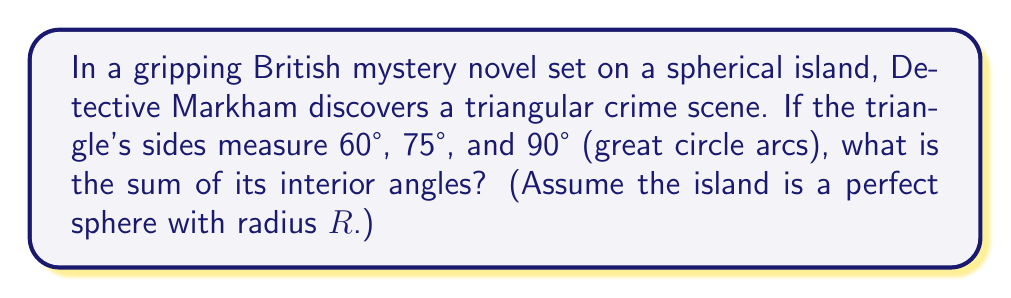Can you solve this math problem? To solve this problem, we'll use the formula for the area of a spherical triangle and its relation to the angle sum:

1) The area $A$ of a spherical triangle on a sphere of radius $R$ is given by:
   
   $$ A = R^2(α + β + γ - π) $$
   
   where $α$, $β$, and $γ$ are the interior angles of the triangle.

2) The angle sum $S = α + β + γ$ is related to the area by:
   
   $$ S = \frac{A}{R^2} + π $$

3) We need to find the area using the side lengths. The area formula for a spherical triangle with sides $a$, $b$, and $c$ (in radians) is:

   $$ \tan(\frac{A}{4R^2}) = \sqrt{\tan(\frac{s}{2})\tan(\frac{s-a}{2})\tan(\frac{s-b}{2})\tan(\frac{s-c}{2})} $$

   where $s = \frac{a+b+c}{2}$ is the semi-perimeter.

4) Convert the given sides to radians:
   $a = 60° = \frac{π}{3}$, $b = 75° = \frac{5π}{12}$, $c = 90° = \frac{π}{2}$

5) Calculate $s$:
   $$ s = \frac{\frac{π}{3} + \frac{5π}{12} + \frac{π}{2}}{2} = \frac{25π}{24} $$

6) Substitute into the area formula:

   $$ \tan(\frac{A}{4R^2}) = \sqrt{\tan(\frac{25π}{48})\tan(\frac{7π}{48})\tan(\frac{5π}{48})\tan(\frac{π}{48})} $$

7) Solve for $A$:
   
   $$ A ≈ 0.4636R^2 $$

8) Finally, calculate the angle sum:
   
   $$ S = \frac{A}{R^2} + π ≈ 0.4636 + π ≈ 3.6052 \text{ radians} $$

9) Convert to degrees:
   
   $$ S ≈ 3.6052 \cdot \frac{180°}{π} ≈ 206.6° $$
Answer: $206.6°$ 